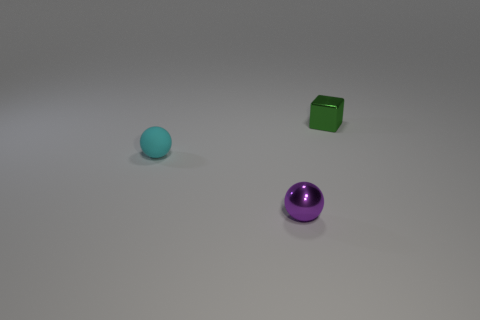Add 2 tiny green cubes. How many objects exist? 5 Subtract all balls. How many objects are left? 1 Subtract all brown metal cylinders. Subtract all small cyan rubber things. How many objects are left? 2 Add 1 cyan rubber objects. How many cyan rubber objects are left? 2 Add 1 large brown blocks. How many large brown blocks exist? 1 Subtract 0 cyan cylinders. How many objects are left? 3 